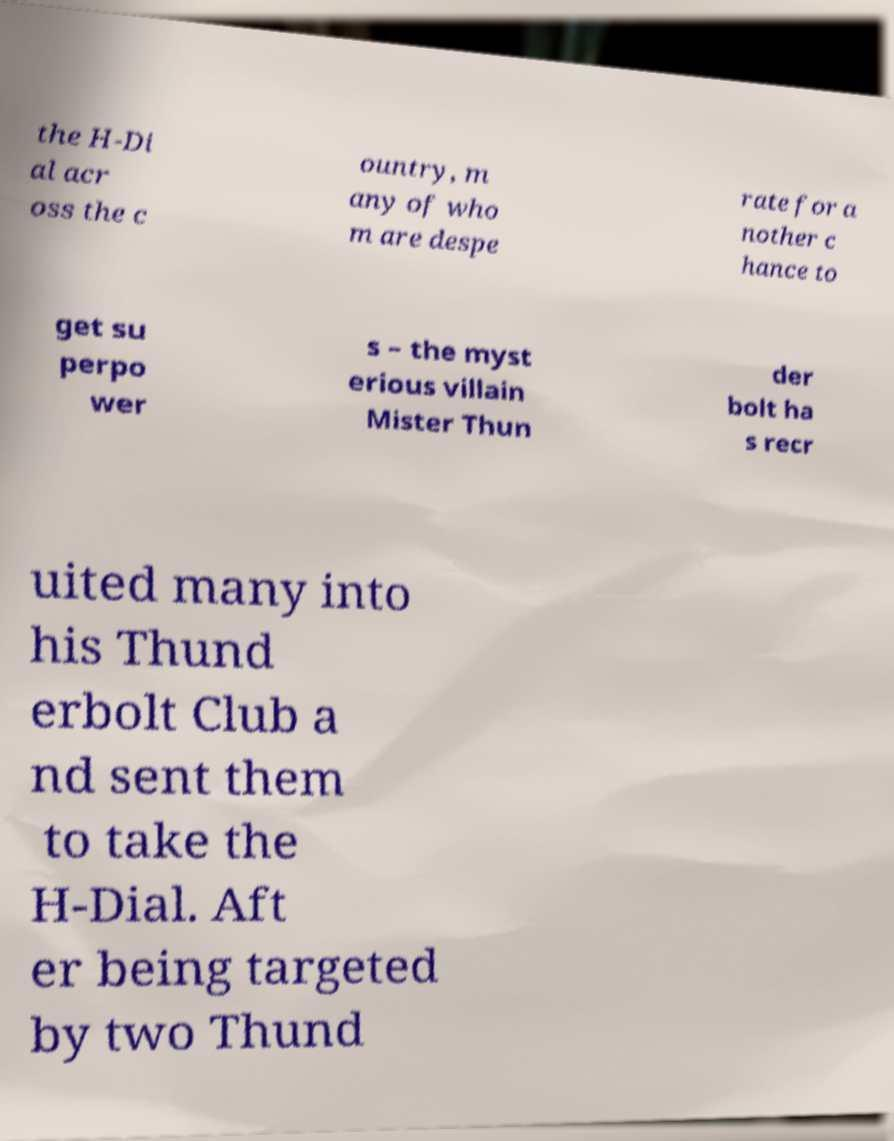Could you assist in decoding the text presented in this image and type it out clearly? the H-Di al acr oss the c ountry, m any of who m are despe rate for a nother c hance to get su perpo wer s – the myst erious villain Mister Thun der bolt ha s recr uited many into his Thund erbolt Club a nd sent them to take the H-Dial. Aft er being targeted by two Thund 